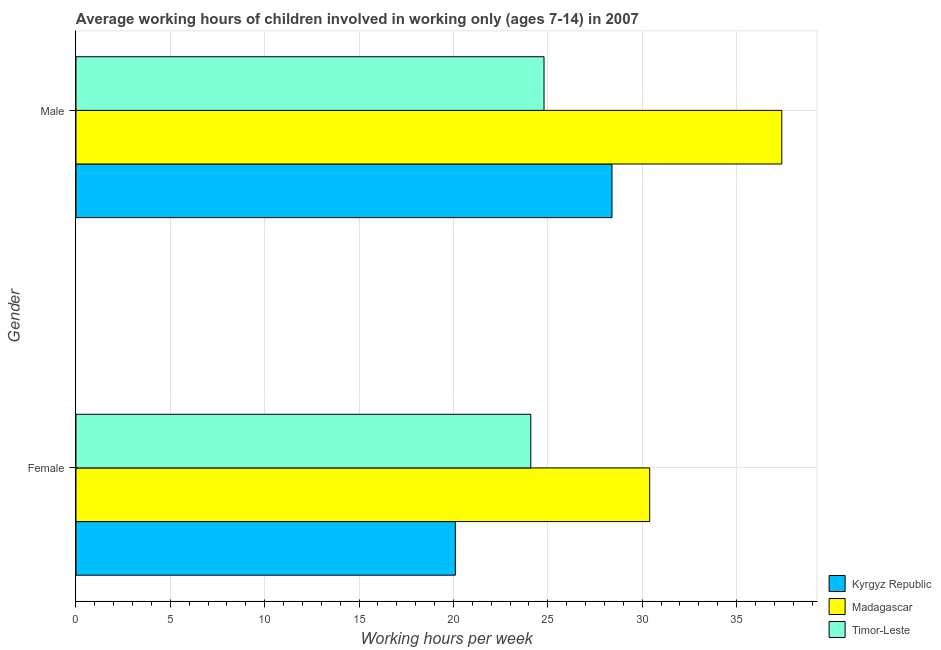How many different coloured bars are there?
Keep it short and to the point. 3. How many groups of bars are there?
Keep it short and to the point. 2. Are the number of bars on each tick of the Y-axis equal?
Your response must be concise. Yes. How many bars are there on the 1st tick from the top?
Your response must be concise. 3. How many bars are there on the 1st tick from the bottom?
Ensure brevity in your answer.  3. What is the label of the 2nd group of bars from the top?
Your answer should be very brief. Female. What is the average working hour of female children in Timor-Leste?
Provide a short and direct response. 24.1. Across all countries, what is the maximum average working hour of female children?
Make the answer very short. 30.4. Across all countries, what is the minimum average working hour of female children?
Your response must be concise. 20.1. In which country was the average working hour of male children maximum?
Offer a terse response. Madagascar. In which country was the average working hour of female children minimum?
Your answer should be very brief. Kyrgyz Republic. What is the total average working hour of male children in the graph?
Provide a short and direct response. 90.6. What is the difference between the average working hour of female children in Kyrgyz Republic and that in Madagascar?
Give a very brief answer. -10.3. What is the difference between the average working hour of female children in Kyrgyz Republic and the average working hour of male children in Timor-Leste?
Your answer should be compact. -4.7. What is the average average working hour of male children per country?
Your response must be concise. 30.2. What is the difference between the average working hour of female children and average working hour of male children in Kyrgyz Republic?
Ensure brevity in your answer.  -8.3. In how many countries, is the average working hour of male children greater than 25 hours?
Make the answer very short. 2. What is the ratio of the average working hour of female children in Madagascar to that in Kyrgyz Republic?
Ensure brevity in your answer.  1.51. Is the average working hour of female children in Timor-Leste less than that in Madagascar?
Your answer should be very brief. Yes. What does the 2nd bar from the top in Female represents?
Offer a terse response. Madagascar. What does the 2nd bar from the bottom in Female represents?
Your answer should be very brief. Madagascar. How many bars are there?
Keep it short and to the point. 6. Are all the bars in the graph horizontal?
Make the answer very short. Yes. What is the difference between two consecutive major ticks on the X-axis?
Offer a terse response. 5. Does the graph contain any zero values?
Give a very brief answer. No. Does the graph contain grids?
Offer a terse response. Yes. Where does the legend appear in the graph?
Offer a terse response. Bottom right. How many legend labels are there?
Your response must be concise. 3. What is the title of the graph?
Your answer should be very brief. Average working hours of children involved in working only (ages 7-14) in 2007. What is the label or title of the X-axis?
Your answer should be compact. Working hours per week. What is the label or title of the Y-axis?
Provide a succinct answer. Gender. What is the Working hours per week in Kyrgyz Republic in Female?
Give a very brief answer. 20.1. What is the Working hours per week in Madagascar in Female?
Provide a succinct answer. 30.4. What is the Working hours per week of Timor-Leste in Female?
Your response must be concise. 24.1. What is the Working hours per week in Kyrgyz Republic in Male?
Your answer should be compact. 28.4. What is the Working hours per week in Madagascar in Male?
Your answer should be compact. 37.4. What is the Working hours per week in Timor-Leste in Male?
Your response must be concise. 24.8. Across all Gender, what is the maximum Working hours per week of Kyrgyz Republic?
Give a very brief answer. 28.4. Across all Gender, what is the maximum Working hours per week of Madagascar?
Ensure brevity in your answer.  37.4. Across all Gender, what is the maximum Working hours per week of Timor-Leste?
Keep it short and to the point. 24.8. Across all Gender, what is the minimum Working hours per week of Kyrgyz Republic?
Provide a succinct answer. 20.1. Across all Gender, what is the minimum Working hours per week of Madagascar?
Your response must be concise. 30.4. Across all Gender, what is the minimum Working hours per week in Timor-Leste?
Give a very brief answer. 24.1. What is the total Working hours per week in Kyrgyz Republic in the graph?
Your response must be concise. 48.5. What is the total Working hours per week of Madagascar in the graph?
Your answer should be compact. 67.8. What is the total Working hours per week in Timor-Leste in the graph?
Provide a succinct answer. 48.9. What is the difference between the Working hours per week of Kyrgyz Republic in Female and that in Male?
Give a very brief answer. -8.3. What is the difference between the Working hours per week in Madagascar in Female and that in Male?
Ensure brevity in your answer.  -7. What is the difference between the Working hours per week of Kyrgyz Republic in Female and the Working hours per week of Madagascar in Male?
Provide a short and direct response. -17.3. What is the difference between the Working hours per week in Kyrgyz Republic in Female and the Working hours per week in Timor-Leste in Male?
Offer a terse response. -4.7. What is the average Working hours per week of Kyrgyz Republic per Gender?
Your answer should be compact. 24.25. What is the average Working hours per week of Madagascar per Gender?
Give a very brief answer. 33.9. What is the average Working hours per week in Timor-Leste per Gender?
Offer a terse response. 24.45. What is the difference between the Working hours per week in Kyrgyz Republic and Working hours per week in Madagascar in Female?
Your response must be concise. -10.3. What is the difference between the Working hours per week of Madagascar and Working hours per week of Timor-Leste in Female?
Provide a short and direct response. 6.3. What is the difference between the Working hours per week of Kyrgyz Republic and Working hours per week of Madagascar in Male?
Ensure brevity in your answer.  -9. What is the difference between the Working hours per week of Madagascar and Working hours per week of Timor-Leste in Male?
Provide a succinct answer. 12.6. What is the ratio of the Working hours per week in Kyrgyz Republic in Female to that in Male?
Provide a short and direct response. 0.71. What is the ratio of the Working hours per week of Madagascar in Female to that in Male?
Make the answer very short. 0.81. What is the ratio of the Working hours per week of Timor-Leste in Female to that in Male?
Provide a succinct answer. 0.97. What is the difference between the highest and the second highest Working hours per week in Kyrgyz Republic?
Provide a succinct answer. 8.3. What is the difference between the highest and the second highest Working hours per week of Timor-Leste?
Offer a terse response. 0.7. What is the difference between the highest and the lowest Working hours per week in Kyrgyz Republic?
Keep it short and to the point. 8.3. What is the difference between the highest and the lowest Working hours per week of Madagascar?
Keep it short and to the point. 7. What is the difference between the highest and the lowest Working hours per week of Timor-Leste?
Your answer should be very brief. 0.7. 